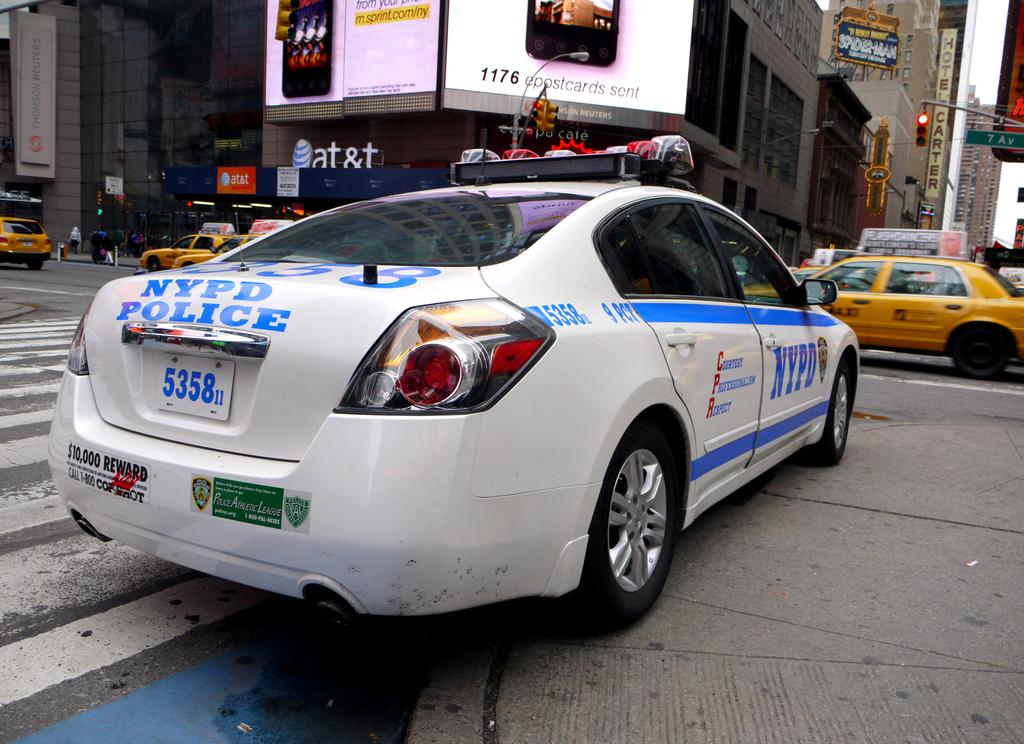<image>
Describe the image concisely. a city street with a NYPD car and license plate 5358 